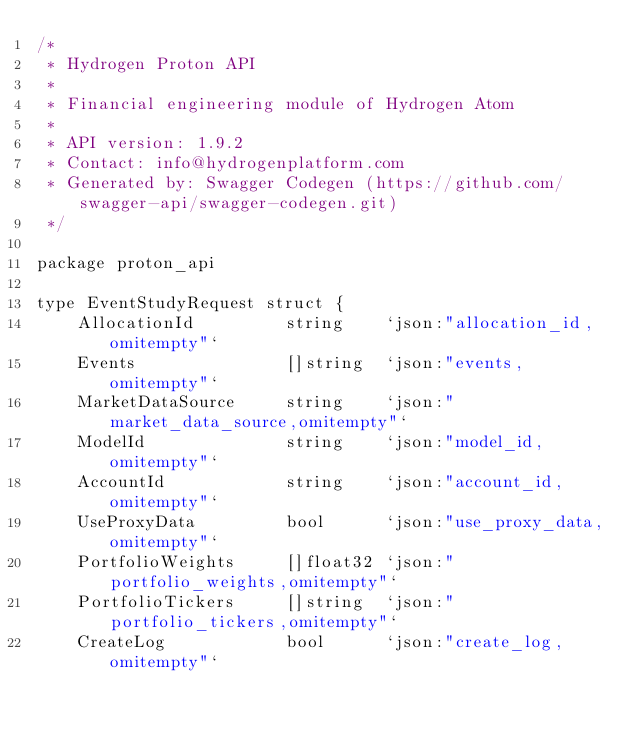Convert code to text. <code><loc_0><loc_0><loc_500><loc_500><_Go_>/*
 * Hydrogen Proton API
 *
 * Financial engineering module of Hydrogen Atom
 *
 * API version: 1.9.2
 * Contact: info@hydrogenplatform.com
 * Generated by: Swagger Codegen (https://github.com/swagger-api/swagger-codegen.git)
 */

package proton_api

type EventStudyRequest struct {
	AllocationId         string    `json:"allocation_id,omitempty"`
	Events               []string  `json:"events,omitempty"`
	MarketDataSource     string    `json:"market_data_source,omitempty"`
	ModelId              string    `json:"model_id,omitempty"`
	AccountId            string    `json:"account_id,omitempty"`
	UseProxyData         bool      `json:"use_proxy_data,omitempty"`
	PortfolioWeights     []float32 `json:"portfolio_weights,omitempty"`
	PortfolioTickers     []string  `json:"portfolio_tickers,omitempty"`
	CreateLog            bool      `json:"create_log,omitempty"`</code> 